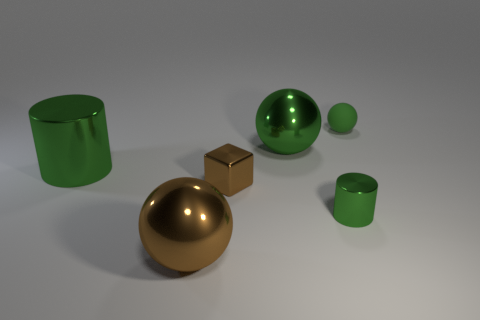What color is the tiny matte ball?
Give a very brief answer. Green. There is a tiny matte object that is the same color as the small cylinder; what shape is it?
Offer a very short reply. Sphere. What is the color of the cylinder that is the same size as the rubber thing?
Provide a short and direct response. Green. What number of rubber things are either large brown things or big cylinders?
Your response must be concise. 0. What number of tiny objects are both in front of the big metallic cylinder and to the right of the tiny cylinder?
Your response must be concise. 0. Is there anything else that has the same shape as the big brown shiny object?
Make the answer very short. Yes. There is a green object that is in front of the big green shiny cylinder; is its size the same as the rubber object that is to the right of the metallic block?
Your response must be concise. Yes. What number of objects are tiny brown metallic cylinders or big objects that are behind the small metallic cylinder?
Provide a short and direct response. 2. How big is the green sphere in front of the green rubber sphere?
Your answer should be compact. Large. Is the number of green shiny spheres on the right side of the green rubber ball less than the number of big spheres that are on the left side of the brown block?
Your response must be concise. Yes. 